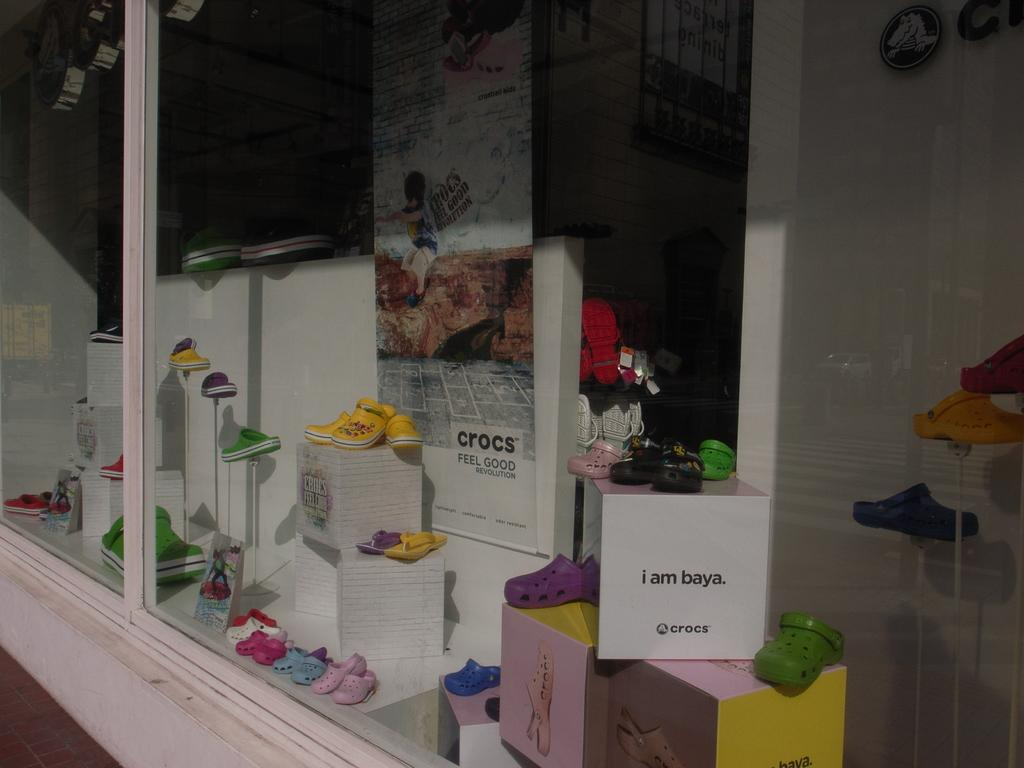<image>
Create a compact narrative representing the image presented. A display of different colored Crocs shoes and various slogans, including "i am baya." 